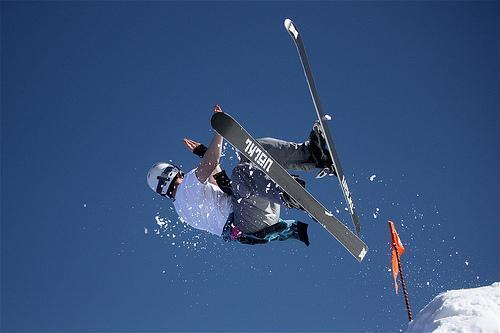How many flags are in the image?
Give a very brief answer. 1. 